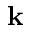Convert formula to latex. <formula><loc_0><loc_0><loc_500><loc_500>k</formula> 